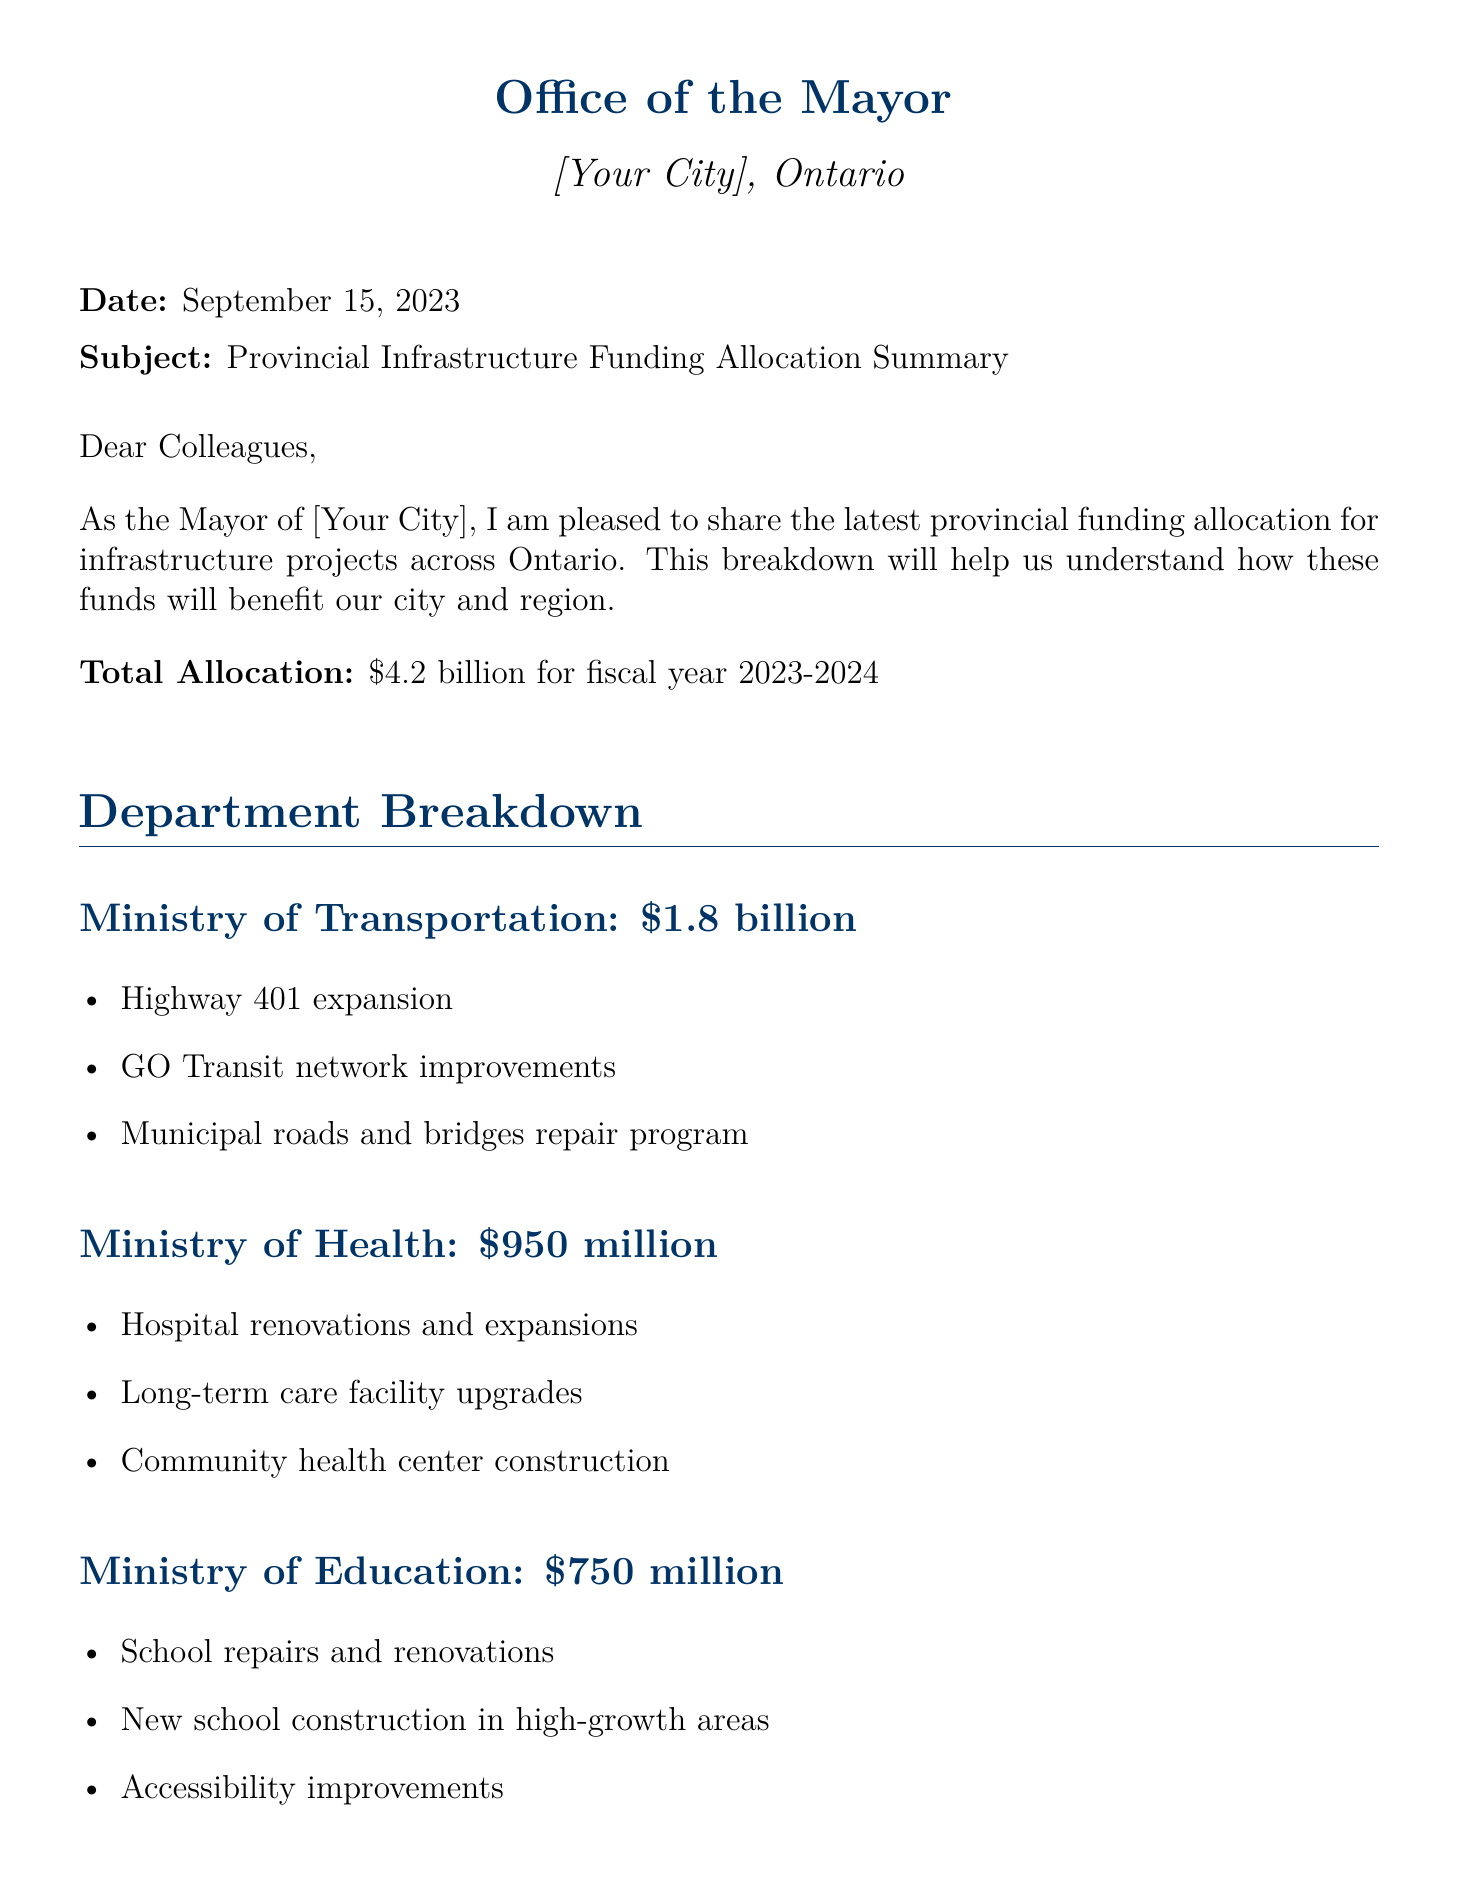what is the total allocation for fiscal year 2023-2024? The total allocation is stated clearly in the document as $4.2 billion.
Answer: $4.2 billion how much funding is allocated to the Ministry of Transportation? The document specifies the funding allocation for the Ministry of Transportation as $1.8 billion.
Answer: $1.8 billion what types of projects are included under the Ministry of Health funding? The document lists specific projects funded by the Ministry of Health, including hospital renovations, long-term care upgrades, and community health centers.
Answer: Hospital renovations and expansions, long-term care facility upgrades, community health center construction which ministry receives the least funding? The document shows a breakdown of funding by ministry, revealing that the Ministry of Infrastructure receives the least at $300 million.
Answer: Ministry of Infrastructure what is one of the projects under the Ministry of the Environment, Conservation and Parks? The document outlines projects, one of which is clean water infrastructure upgrades under the Ministry of the Environment.
Answer: Clean water infrastructure upgrades how many ministries are mentioned in the document? The document provides a breakdown of funding across multiple ministries, specifically five.
Answer: Five what is the purpose of the provincial funding according to the document? The document discusses the funding's contribution to city growth and development purposes.
Answer: Growth and development what is the date of the document? The document provides the date in the header as September 15, 2023.
Answer: September 15, 2023 